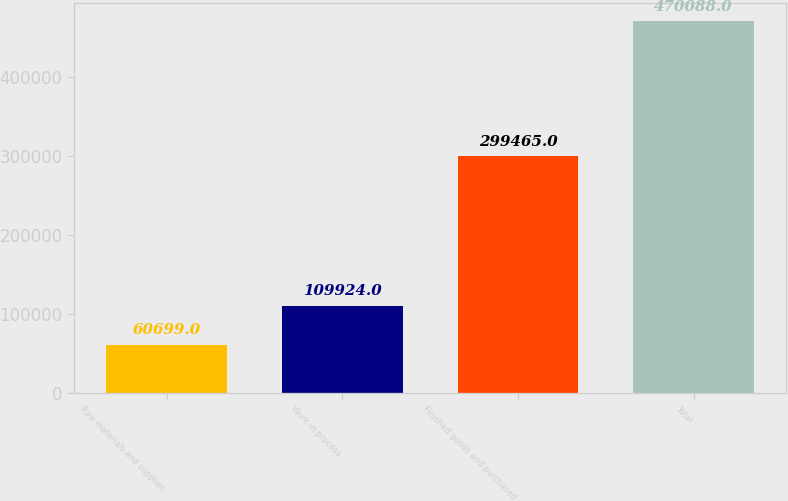Convert chart. <chart><loc_0><loc_0><loc_500><loc_500><bar_chart><fcel>Raw materials and supplies<fcel>Work in process<fcel>Finished goods and purchased<fcel>Total<nl><fcel>60699<fcel>109924<fcel>299465<fcel>470088<nl></chart> 